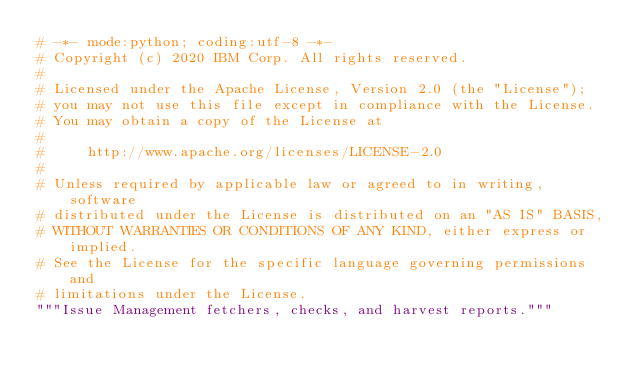Convert code to text. <code><loc_0><loc_0><loc_500><loc_500><_Python_># -*- mode:python; coding:utf-8 -*-
# Copyright (c) 2020 IBM Corp. All rights reserved.
#
# Licensed under the Apache License, Version 2.0 (the "License");
# you may not use this file except in compliance with the License.
# You may obtain a copy of the License at
#
#     http://www.apache.org/licenses/LICENSE-2.0
#
# Unless required by applicable law or agreed to in writing, software
# distributed under the License is distributed on an "AS IS" BASIS,
# WITHOUT WARRANTIES OR CONDITIONS OF ANY KIND, either express or implied.
# See the License for the specific language governing permissions and
# limitations under the License.
"""Issue Management fetchers, checks, and harvest reports."""
</code> 